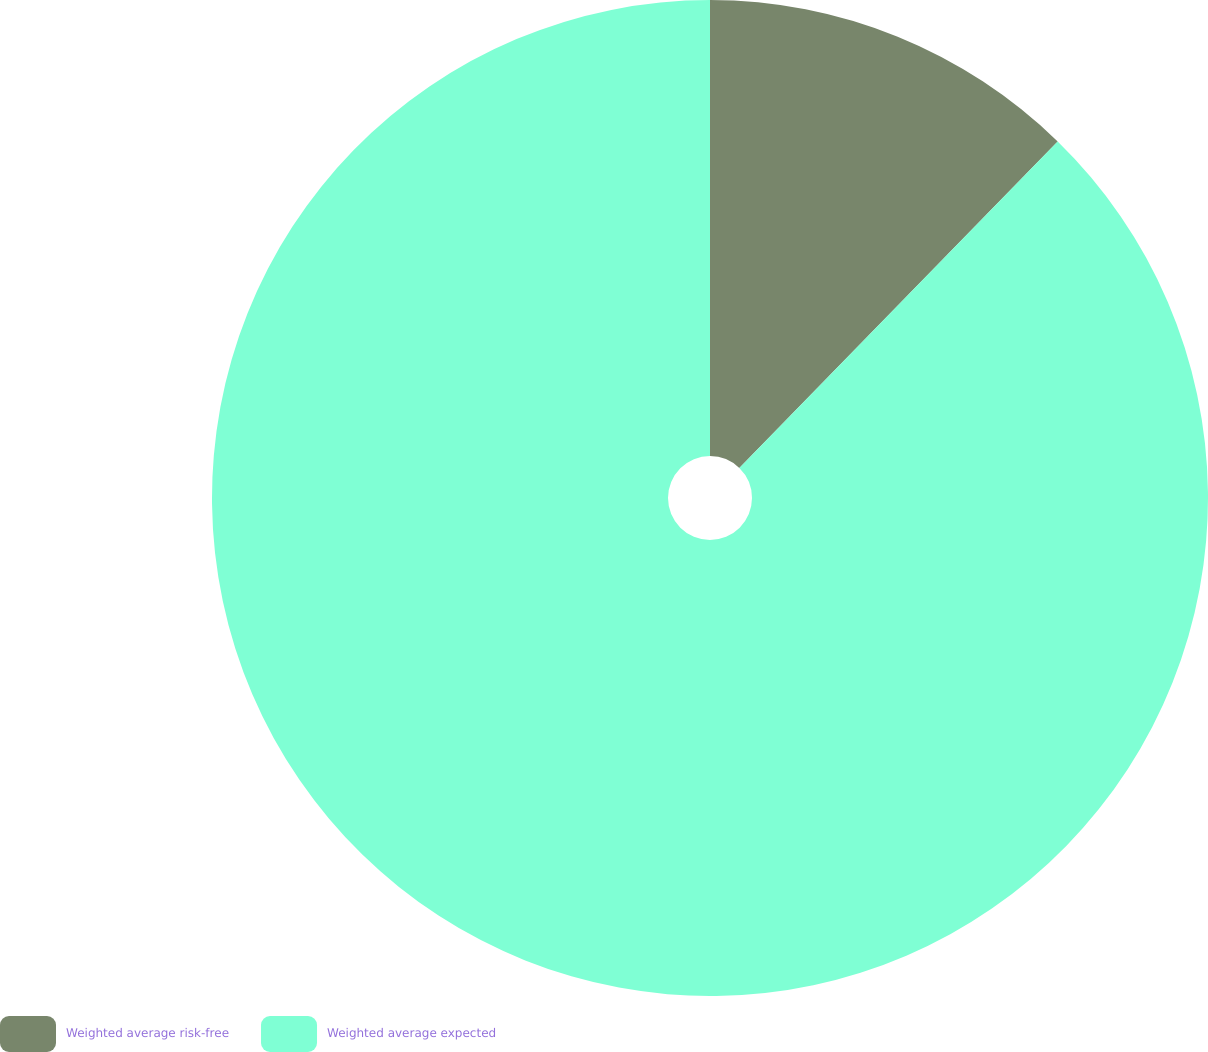<chart> <loc_0><loc_0><loc_500><loc_500><pie_chart><fcel>Weighted average risk-free<fcel>Weighted average expected<nl><fcel>12.3%<fcel>87.7%<nl></chart> 